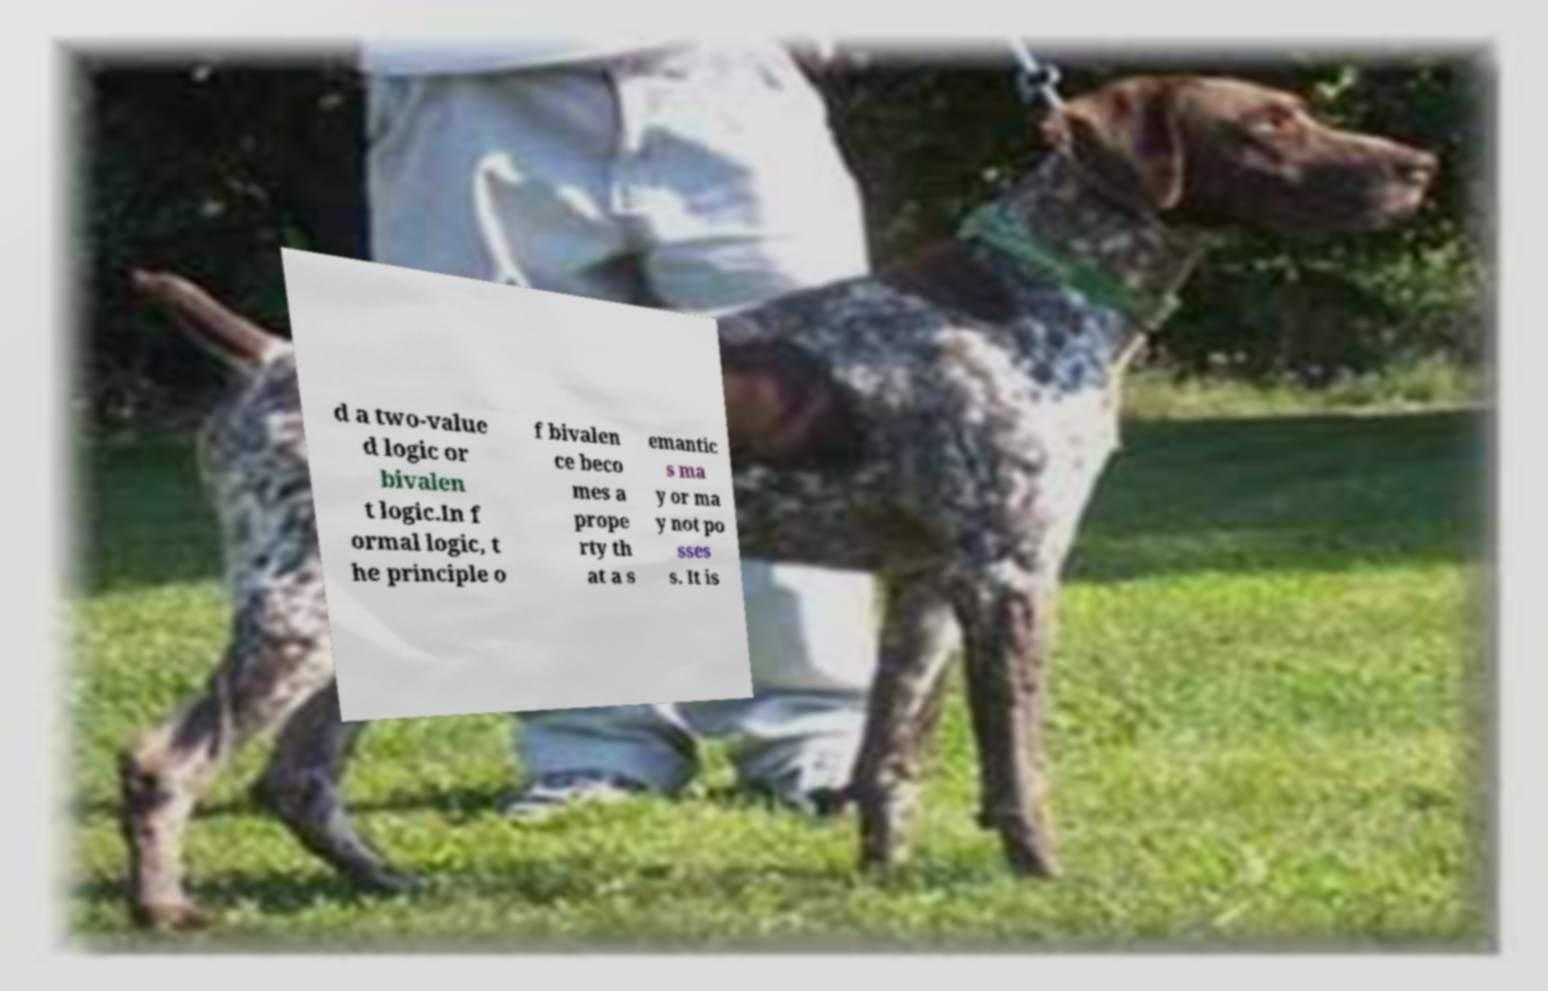I need the written content from this picture converted into text. Can you do that? d a two-value d logic or bivalen t logic.In f ormal logic, t he principle o f bivalen ce beco mes a prope rty th at a s emantic s ma y or ma y not po sses s. It is 